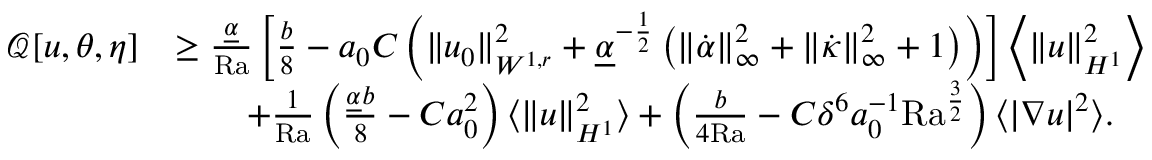Convert formula to latex. <formula><loc_0><loc_0><loc_500><loc_500>\begin{array} { r l } { \mathcal { Q } [ u , \theta , \eta ] } & { \geq \frac { \underline { \alpha } } { R a } \left [ \frac { b } { 8 } - a _ { 0 } C \left ( \| u _ { 0 } \| _ { W ^ { 1 , r } } ^ { 2 } + \underline { \alpha } ^ { - \frac { 1 } { 2 } } \left ( \| \dot { \alpha } \| _ { \infty } ^ { 2 } + \| \dot { \kappa } \| _ { \infty } ^ { 2 } + 1 \right ) \right ) \right ] \left \langle \| u \| _ { H ^ { 1 } } ^ { 2 } \right \rangle } \\ & { \quad + \frac { 1 } { R a } \left ( \frac { \underline { \alpha } b } { 8 } - C a _ { 0 } ^ { 2 } \right ) \langle \| u \| _ { H ^ { 1 } } ^ { 2 } \rangle + \left ( \frac { b } { 4 { R a } } - C \delta ^ { 6 } a _ { 0 } ^ { - 1 } { R a } ^ { \frac { 3 } { 2 } } \right ) \langle | \nabla u | ^ { 2 } \rangle . } \end{array}</formula> 